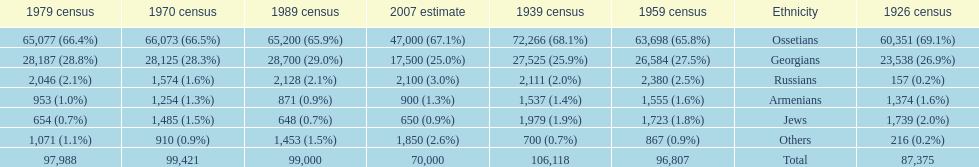How many ethnicity is there? 6. 